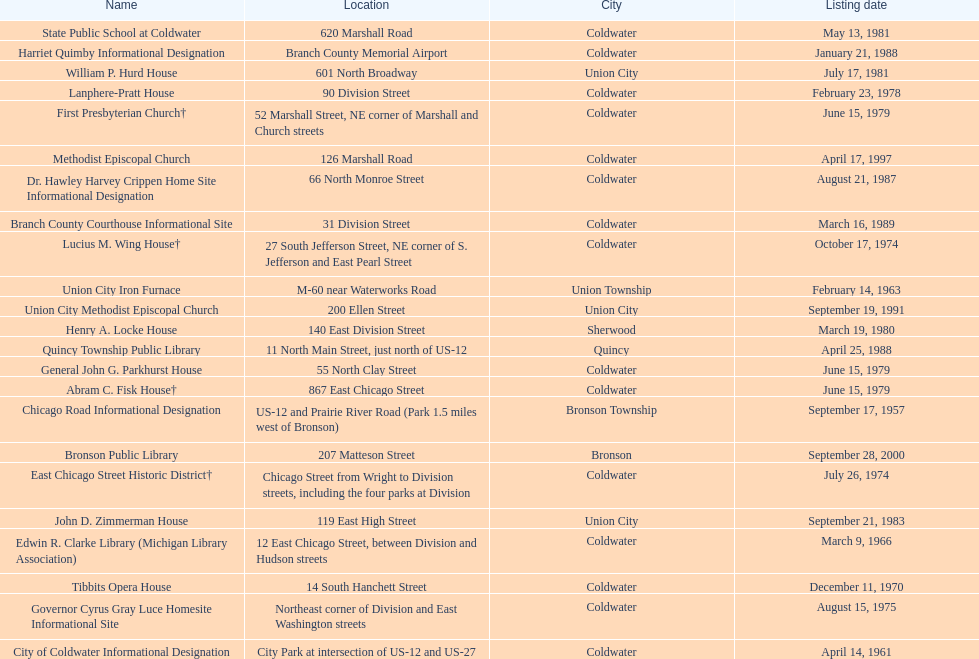Which site was listed earlier, the state public school or the edwin r. clarke library? Edwin R. Clarke Library. 